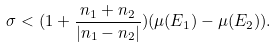<formula> <loc_0><loc_0><loc_500><loc_500>\sigma < ( 1 + \frac { n _ { 1 } + n _ { 2 } } { | n _ { 1 } - n _ { 2 } | } ) ( \mu ( E _ { 1 } ) - \mu ( E _ { 2 } ) ) .</formula> 